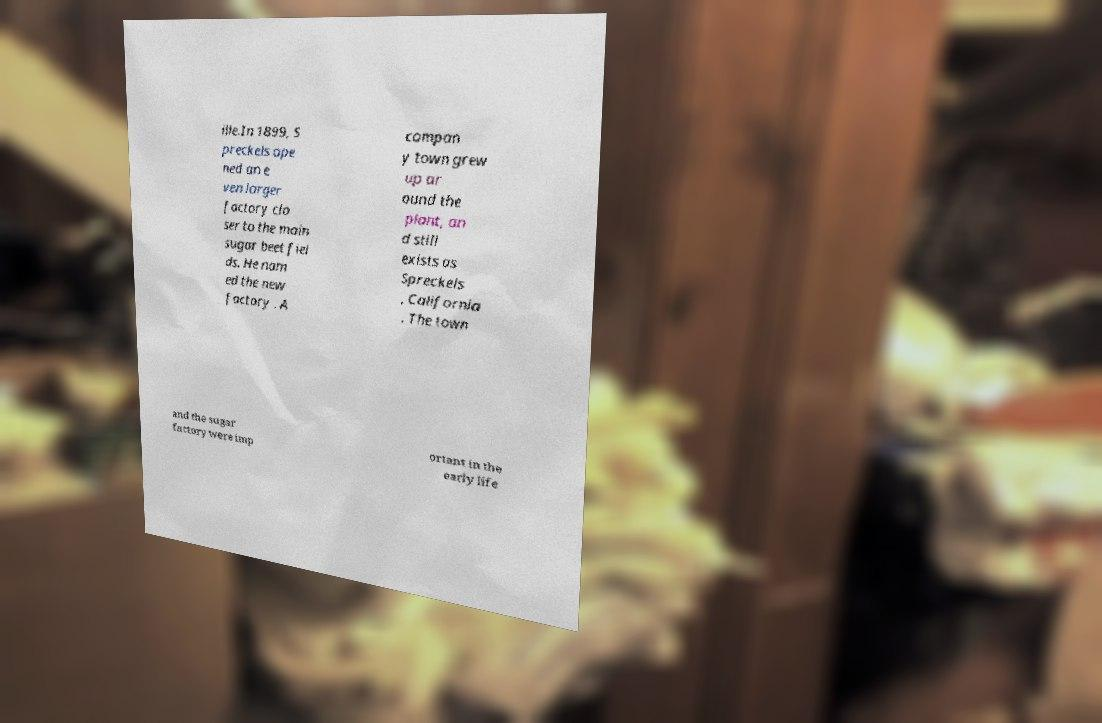I need the written content from this picture converted into text. Can you do that? ille.In 1899, S preckels ope ned an e ven larger factory clo ser to the main sugar beet fiel ds. He nam ed the new factory . A compan y town grew up ar ound the plant, an d still exists as Spreckels , California . The town and the sugar factory were imp ortant in the early life 